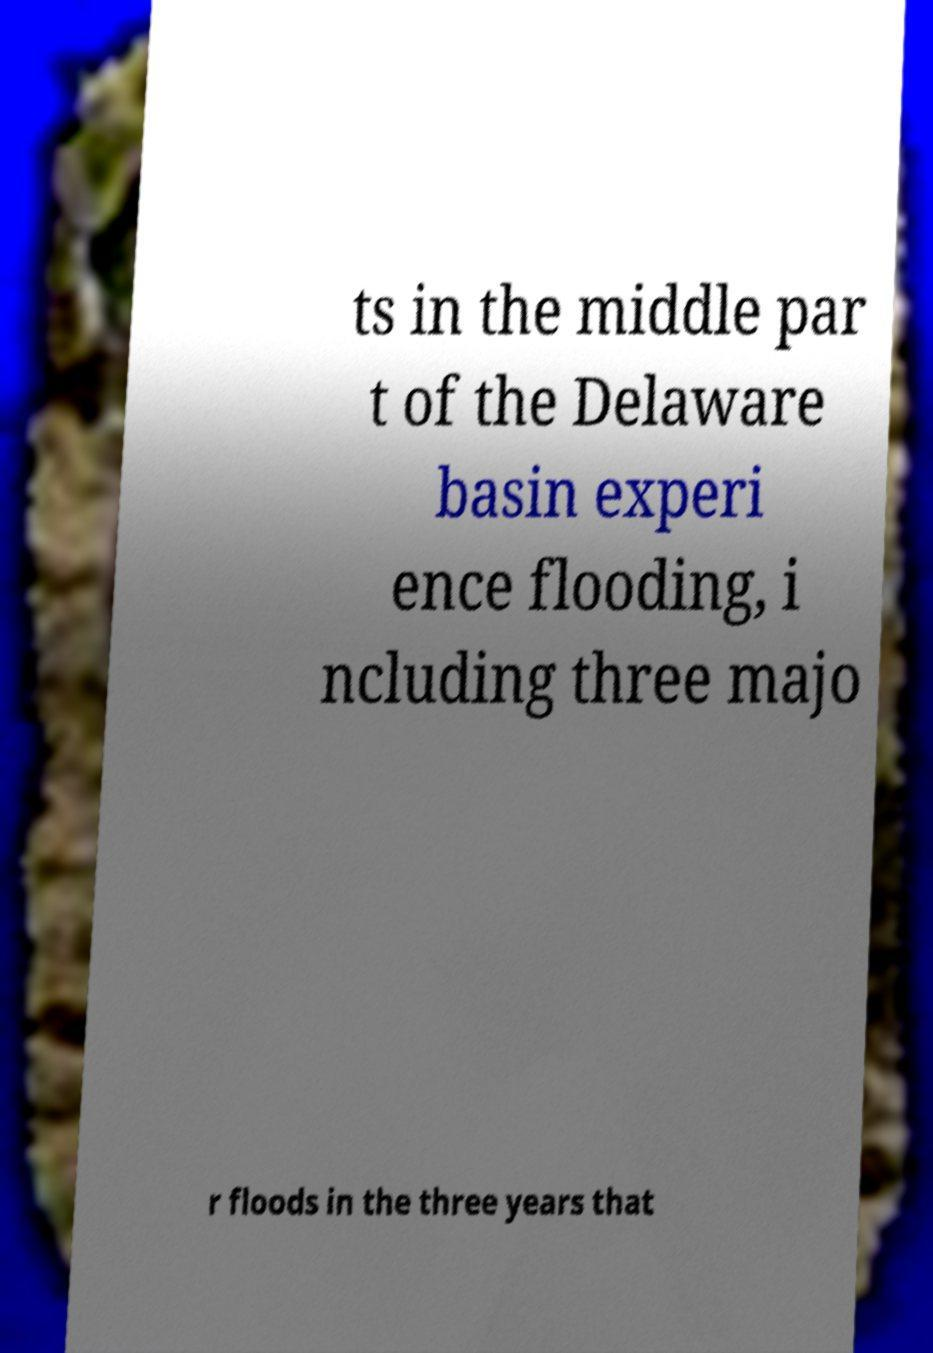Could you assist in decoding the text presented in this image and type it out clearly? ts in the middle par t of the Delaware basin experi ence flooding, i ncluding three majo r floods in the three years that 